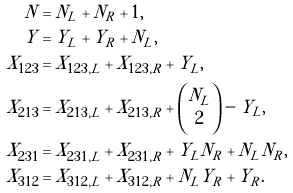<formula> <loc_0><loc_0><loc_500><loc_500>N & = N _ { L } + N _ { R } + 1 , \\ Y & = Y _ { L } + Y _ { R } + N _ { L } , \\ X _ { 1 2 3 } & = X _ { 1 2 3 , L } + X _ { 1 2 3 , R } + Y _ { L } , \\ X _ { 2 1 3 } & = X _ { 2 1 3 , L } + X _ { 2 1 3 , R } + \binom { N _ { L } } 2 - Y _ { L } , \\ X _ { 2 3 1 } & = X _ { 2 3 1 , L } + X _ { 2 3 1 , R } + Y _ { L } N _ { R } + N _ { L } N _ { R } , \\ X _ { 3 1 2 } & = X _ { 3 1 2 , L } + X _ { 3 1 2 , R } + N _ { L } Y _ { R } + Y _ { R } .</formula> 